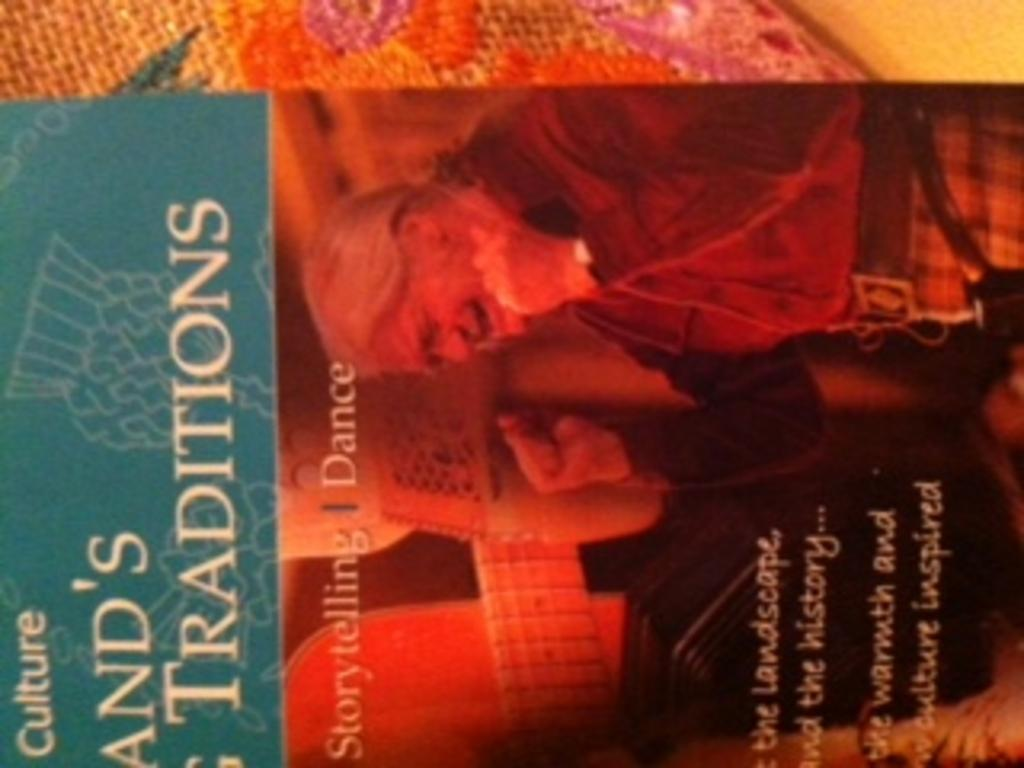<image>
Share a concise interpretation of the image provided. A red book cover with the title And's Traditions. 